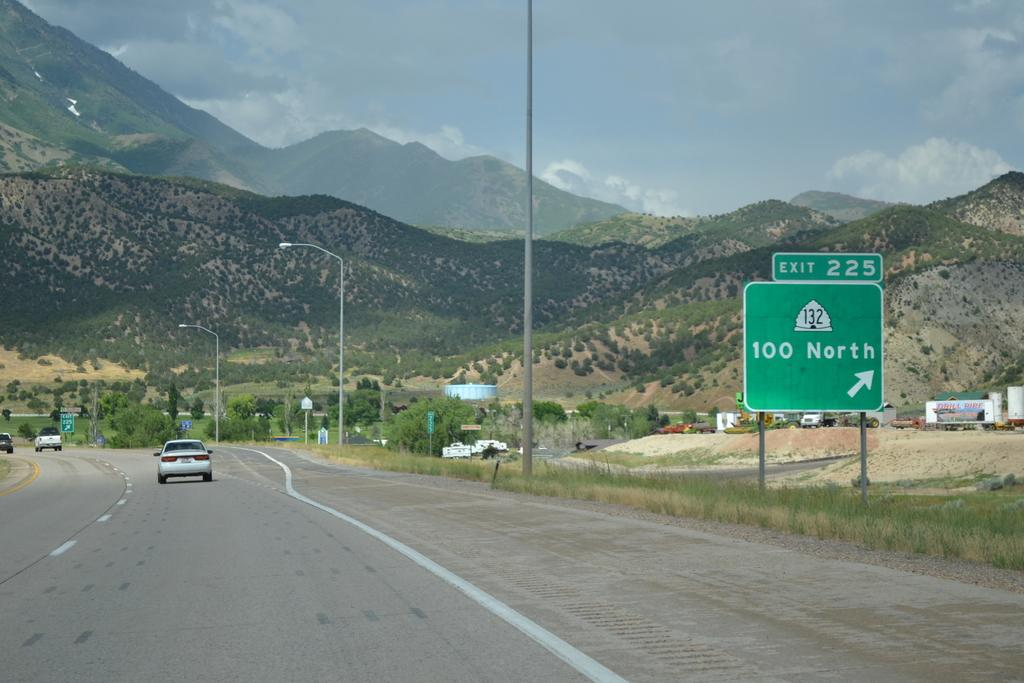<image>
Render a clear and concise summary of the photo. A green sign marks exit 225 to the right. 